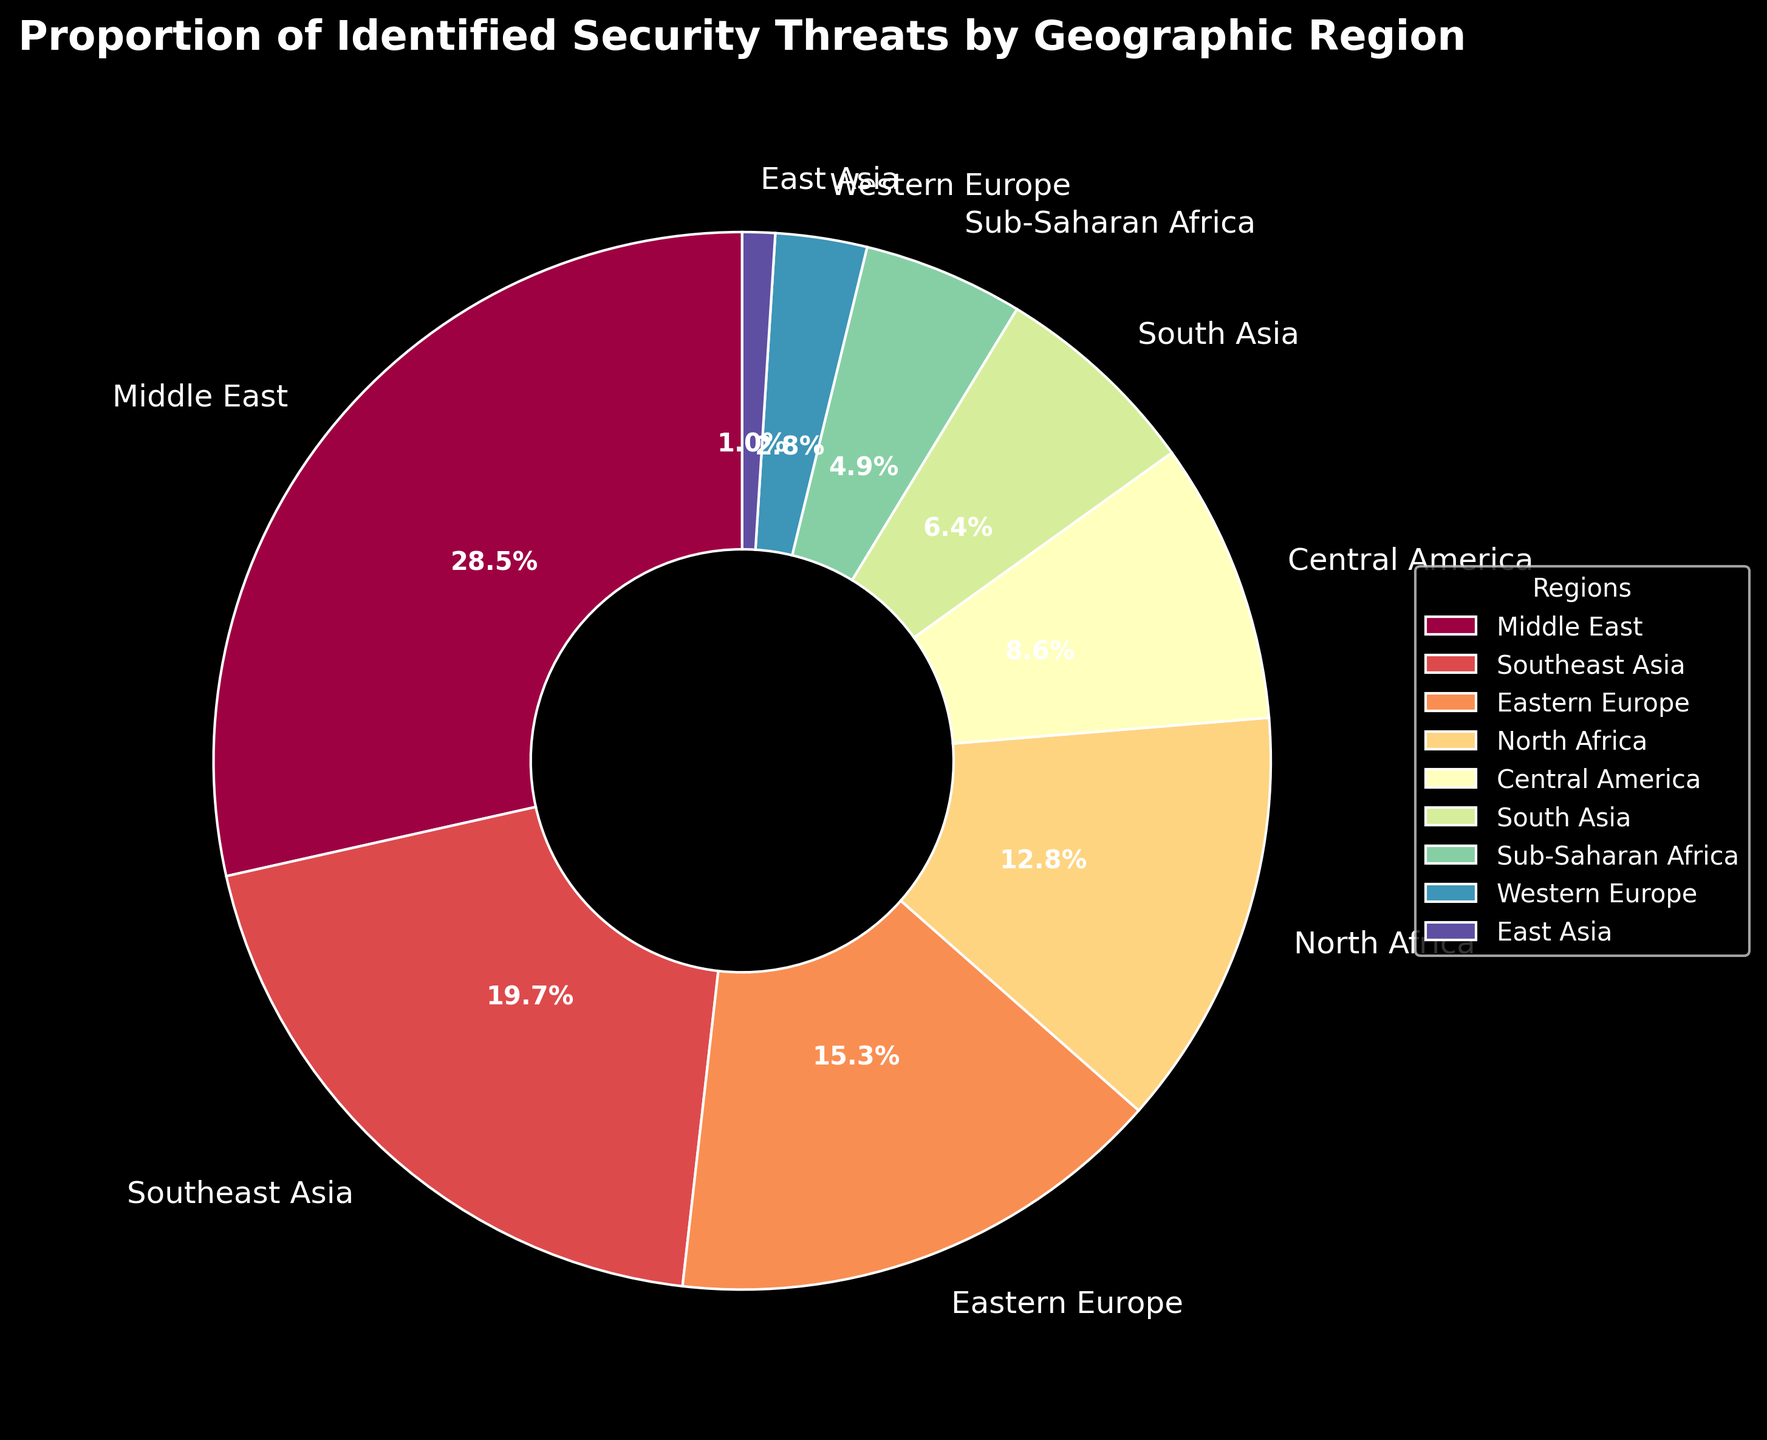Which region has the highest proportion of identified security threats? The region with the highest proportion of identified security threats can be identified by looking for the largest wedge in the pie chart. From the figure, the Middle East has the largest wedge.
Answer: Middle East Which region has the lowest proportion of identified security threats? The region with the lowest proportion of identified security threats can be identified by looking for the smallest wedge in the pie chart. From the figure, East Asia has the smallest wedge.
Answer: East Asia What is the combined percentage of security threats identified in Eastern Europe and North Africa? Add the percentages for Eastern Europe and North Africa. From the figure, Eastern Europe has 15.3% and North Africa has 12.8%. So, 15.3 + 12.8 = 28.1%.
Answer: 28.1% How much greater is the proportion of identified threats in Southeast Asia compared to Central America? Subtract the percentage for Central America from the percentage for Southeast Asia. From the figure, Southeast Asia has 19.7% and Central America has 8.6%. So, 19.7 - 8.6 = 11.1%.
Answer: 11.1% Which region has a larger proportion of identified security threats: Sub-Saharan Africa or South Asia? Compare the percentages for Sub-Saharan Africa and South Asia. From the figure, Sub-Saharan Africa has 4.9% and South Asia has 6.4%. Since 6.4% > 4.9%, South Asia has a larger proportion.
Answer: South Asia What is the combined proportion of security threats identified in the Middle East and Southeast Asia? Add the percentages for the Middle East and Southeast Asia. From the figure, the Middle East has 28.5% and Southeast Asia has 19.7%. So, 28.5 + 19.7 = 48.2%.
Answer: 48.2% How does the proportion of identified threats in Western Europe compare to that in Eastern Europe? Compare the percentages for Western Europe and Eastern Europe. From the figure, Western Europe has 2.8% and Eastern Europe has 15.3%. Thus, Eastern Europe has a much higher proportion of identified threats than Western Europe.
Answer: Eastern Europe has a higher proportion By how much does the proportion of security threats in the Middle East surpass that in North Africa? Subtract the percentage of North Africa from that of the Middle East. From the figure, Middle East has 28.5% and North Africa has 12.8%. So, 28.5 - 12.8 = 15.7%.
Answer: 15.7% What is the second-largest region in terms of identified security threats? Identify the region with the second-largest wedge after the Middle East. From the figure, Southeast Asia has the second-largest proportion of 19.7%.
Answer: Southeast Asia 